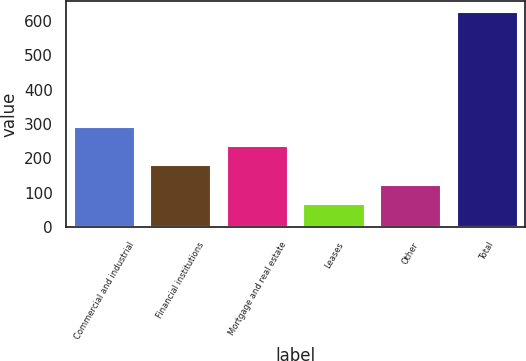Convert chart. <chart><loc_0><loc_0><loc_500><loc_500><bar_chart><fcel>Commercial and industrial<fcel>Financial institutions<fcel>Mortgage and real estate<fcel>Leases<fcel>Other<fcel>Total<nl><fcel>291.6<fcel>179.8<fcel>235.7<fcel>68<fcel>123.9<fcel>627<nl></chart> 